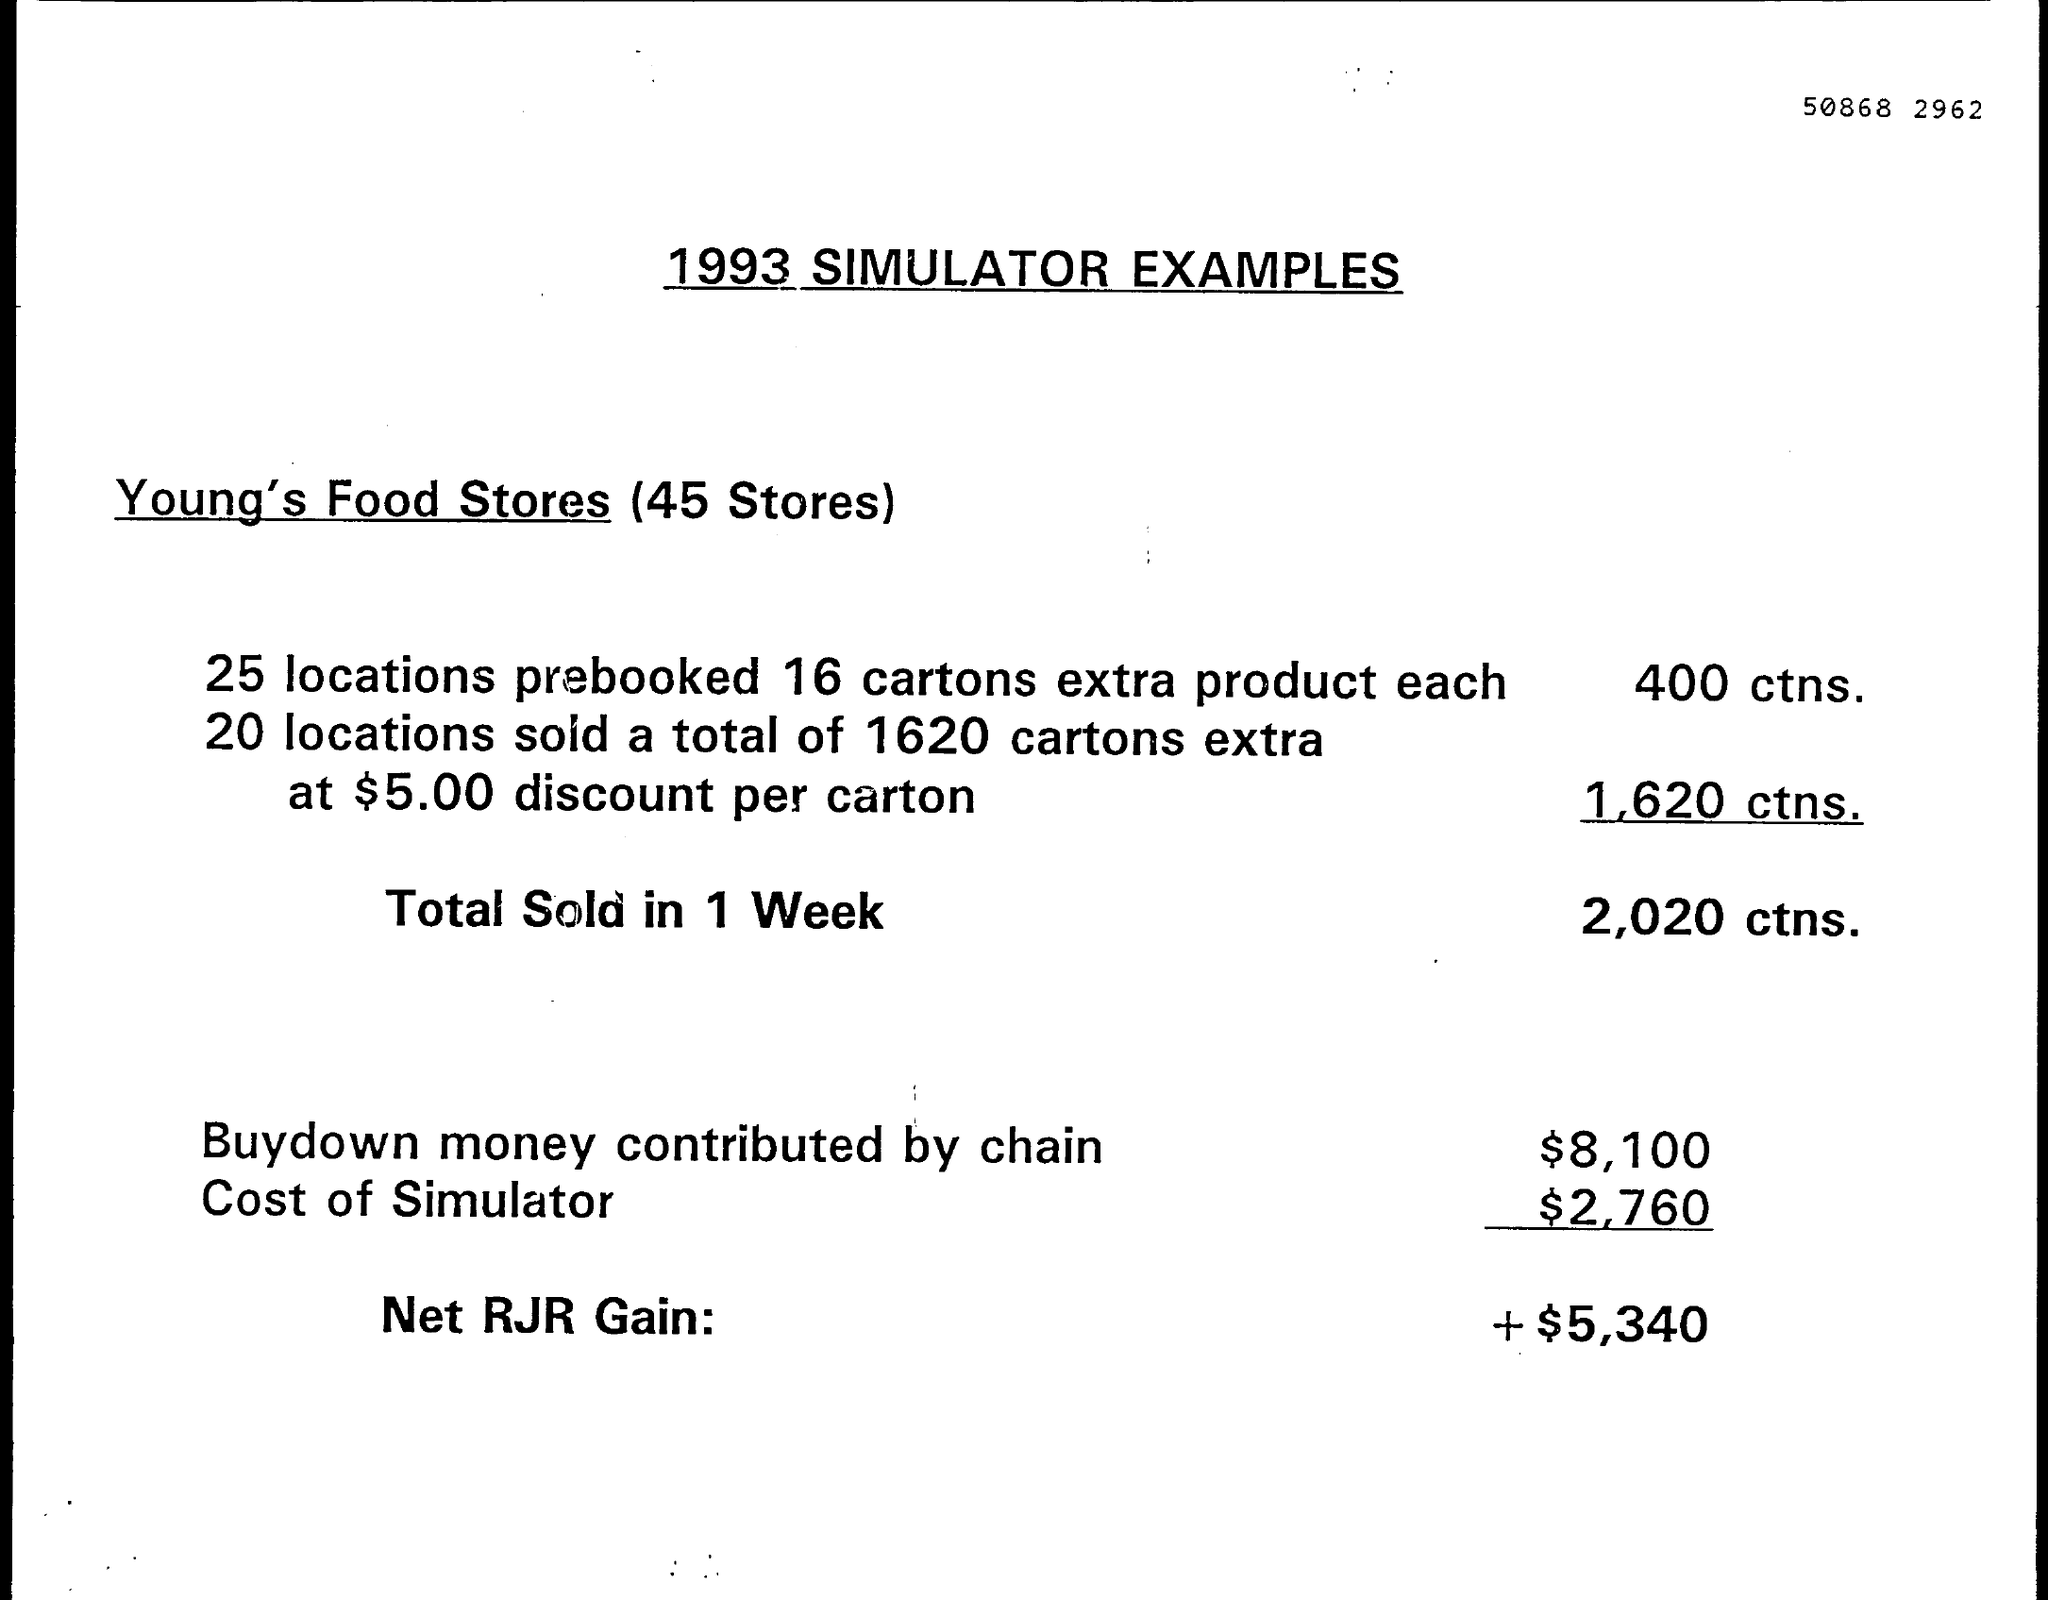Mention a couple of crucial points in this snapshot. The total number of cartons sold in one week in 2020 was. Young's Food Stores currently have 45 stores in total. 